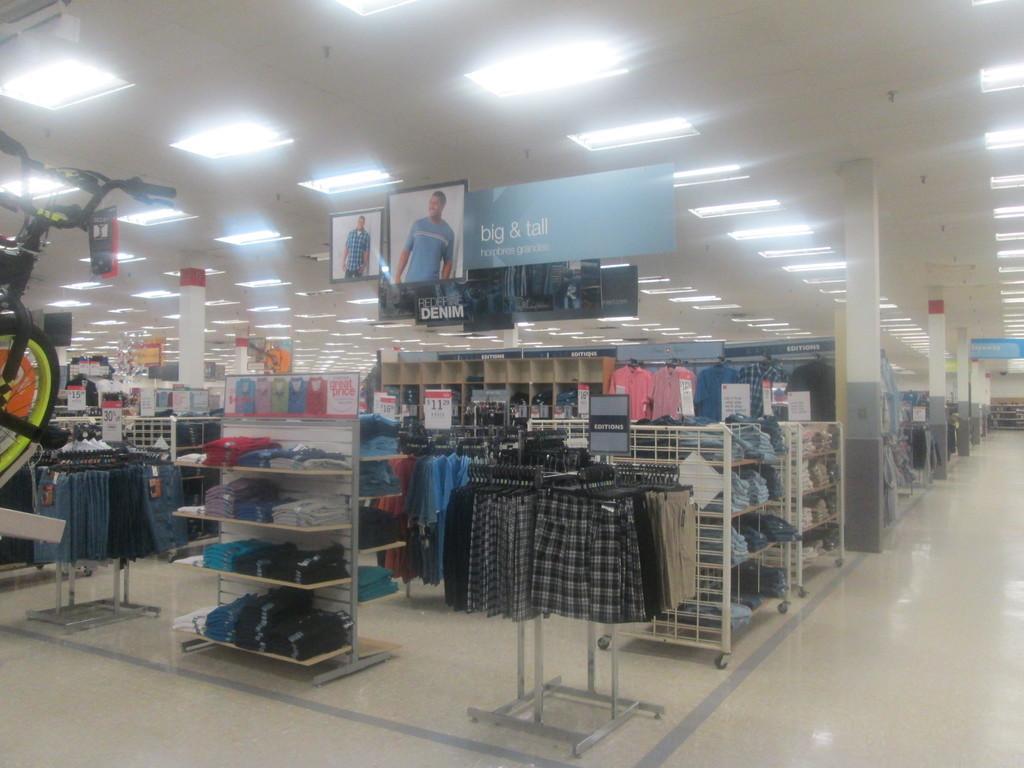How would you summarize this image in a sentence or two? Here we can see clothes hanging to a stand on the floor and there are clothes on the racks and we can see hoardings, pillars and lights on the ceiling and on the left there is a bicycle. 